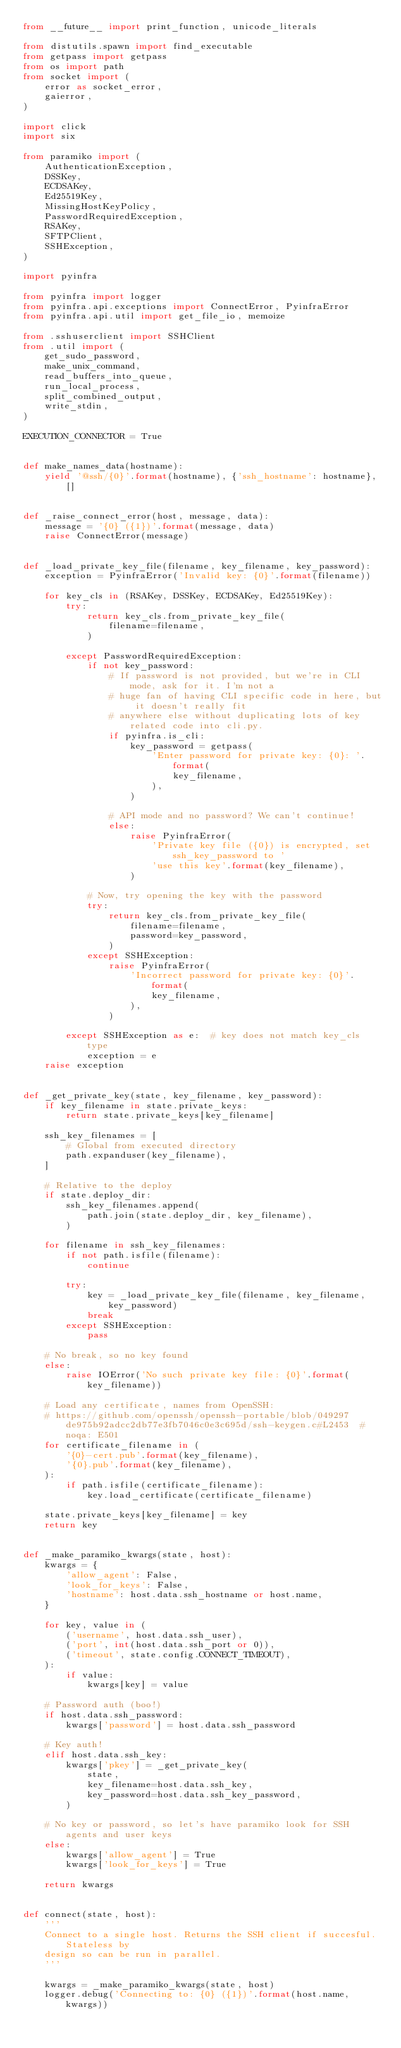Convert code to text. <code><loc_0><loc_0><loc_500><loc_500><_Python_>from __future__ import print_function, unicode_literals

from distutils.spawn import find_executable
from getpass import getpass
from os import path
from socket import (
    error as socket_error,
    gaierror,
)

import click
import six

from paramiko import (
    AuthenticationException,
    DSSKey,
    ECDSAKey,
    Ed25519Key,
    MissingHostKeyPolicy,
    PasswordRequiredException,
    RSAKey,
    SFTPClient,
    SSHException,
)

import pyinfra

from pyinfra import logger
from pyinfra.api.exceptions import ConnectError, PyinfraError
from pyinfra.api.util import get_file_io, memoize

from .sshuserclient import SSHClient
from .util import (
    get_sudo_password,
    make_unix_command,
    read_buffers_into_queue,
    run_local_process,
    split_combined_output,
    write_stdin,
)

EXECUTION_CONNECTOR = True


def make_names_data(hostname):
    yield '@ssh/{0}'.format(hostname), {'ssh_hostname': hostname}, []


def _raise_connect_error(host, message, data):
    message = '{0} ({1})'.format(message, data)
    raise ConnectError(message)


def _load_private_key_file(filename, key_filename, key_password):
    exception = PyinfraError('Invalid key: {0}'.format(filename))

    for key_cls in (RSAKey, DSSKey, ECDSAKey, Ed25519Key):
        try:
            return key_cls.from_private_key_file(
                filename=filename,
            )

        except PasswordRequiredException:
            if not key_password:
                # If password is not provided, but we're in CLI mode, ask for it. I'm not a
                # huge fan of having CLI specific code in here, but it doesn't really fit
                # anywhere else without duplicating lots of key related code into cli.py.
                if pyinfra.is_cli:
                    key_password = getpass(
                        'Enter password for private key: {0}: '.format(
                            key_filename,
                        ),
                    )

                # API mode and no password? We can't continue!
                else:
                    raise PyinfraError(
                        'Private key file ({0}) is encrypted, set ssh_key_password to '
                        'use this key'.format(key_filename),
                    )

            # Now, try opening the key with the password
            try:
                return key_cls.from_private_key_file(
                    filename=filename,
                    password=key_password,
                )
            except SSHException:
                raise PyinfraError(
                    'Incorrect password for private key: {0}'.format(
                        key_filename,
                    ),
                )

        except SSHException as e:  # key does not match key_cls type
            exception = e
    raise exception


def _get_private_key(state, key_filename, key_password):
    if key_filename in state.private_keys:
        return state.private_keys[key_filename]

    ssh_key_filenames = [
        # Global from executed directory
        path.expanduser(key_filename),
    ]

    # Relative to the deploy
    if state.deploy_dir:
        ssh_key_filenames.append(
            path.join(state.deploy_dir, key_filename),
        )

    for filename in ssh_key_filenames:
        if not path.isfile(filename):
            continue

        try:
            key = _load_private_key_file(filename, key_filename, key_password)
            break
        except SSHException:
            pass

    # No break, so no key found
    else:
        raise IOError('No such private key file: {0}'.format(key_filename))

    # Load any certificate, names from OpenSSH:
    # https://github.com/openssh/openssh-portable/blob/049297de975b92adcc2db77e3fb7046c0e3c695d/ssh-keygen.c#L2453  # noqa: E501
    for certificate_filename in (
        '{0}-cert.pub'.format(key_filename),
        '{0}.pub'.format(key_filename),
    ):
        if path.isfile(certificate_filename):
            key.load_certificate(certificate_filename)

    state.private_keys[key_filename] = key
    return key


def _make_paramiko_kwargs(state, host):
    kwargs = {
        'allow_agent': False,
        'look_for_keys': False,
        'hostname': host.data.ssh_hostname or host.name,
    }

    for key, value in (
        ('username', host.data.ssh_user),
        ('port', int(host.data.ssh_port or 0)),
        ('timeout', state.config.CONNECT_TIMEOUT),
    ):
        if value:
            kwargs[key] = value

    # Password auth (boo!)
    if host.data.ssh_password:
        kwargs['password'] = host.data.ssh_password

    # Key auth!
    elif host.data.ssh_key:
        kwargs['pkey'] = _get_private_key(
            state,
            key_filename=host.data.ssh_key,
            key_password=host.data.ssh_key_password,
        )

    # No key or password, so let's have paramiko look for SSH agents and user keys
    else:
        kwargs['allow_agent'] = True
        kwargs['look_for_keys'] = True

    return kwargs


def connect(state, host):
    '''
    Connect to a single host. Returns the SSH client if succesful. Stateless by
    design so can be run in parallel.
    '''

    kwargs = _make_paramiko_kwargs(state, host)
    logger.debug('Connecting to: {0} ({1})'.format(host.name, kwargs))
</code> 